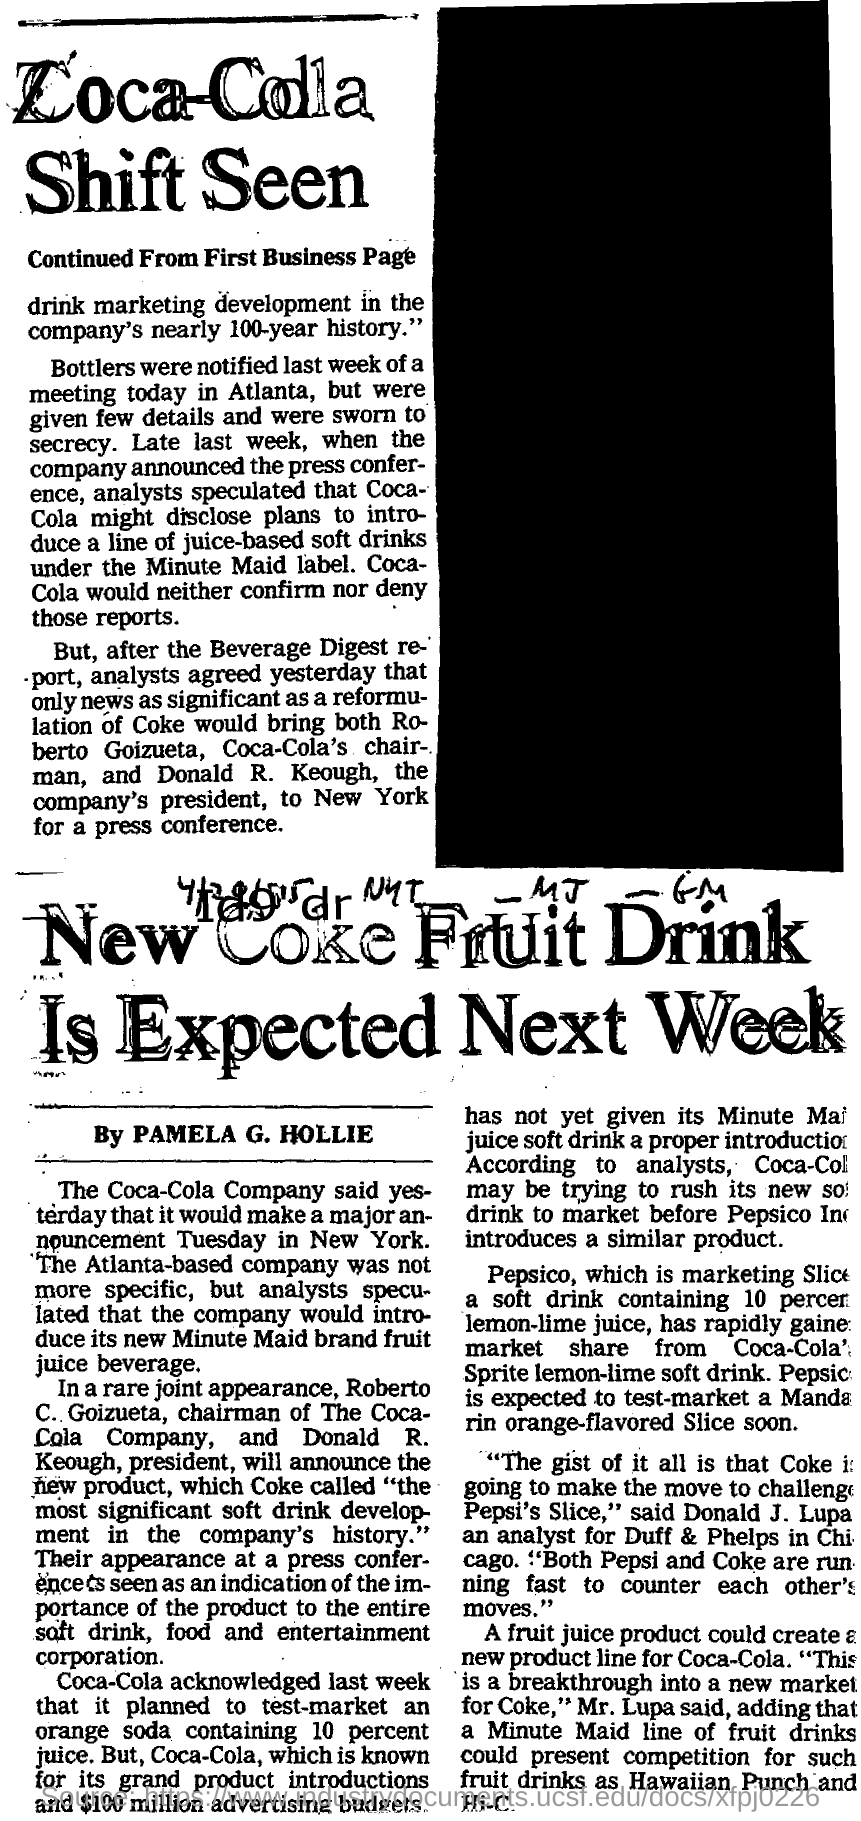Point out several critical features in this image. The meeting was held in Atlanta. The announcement will be held on Tuesday. The chairman of Coca-Cola Company is Roberto C. Goizueta. 